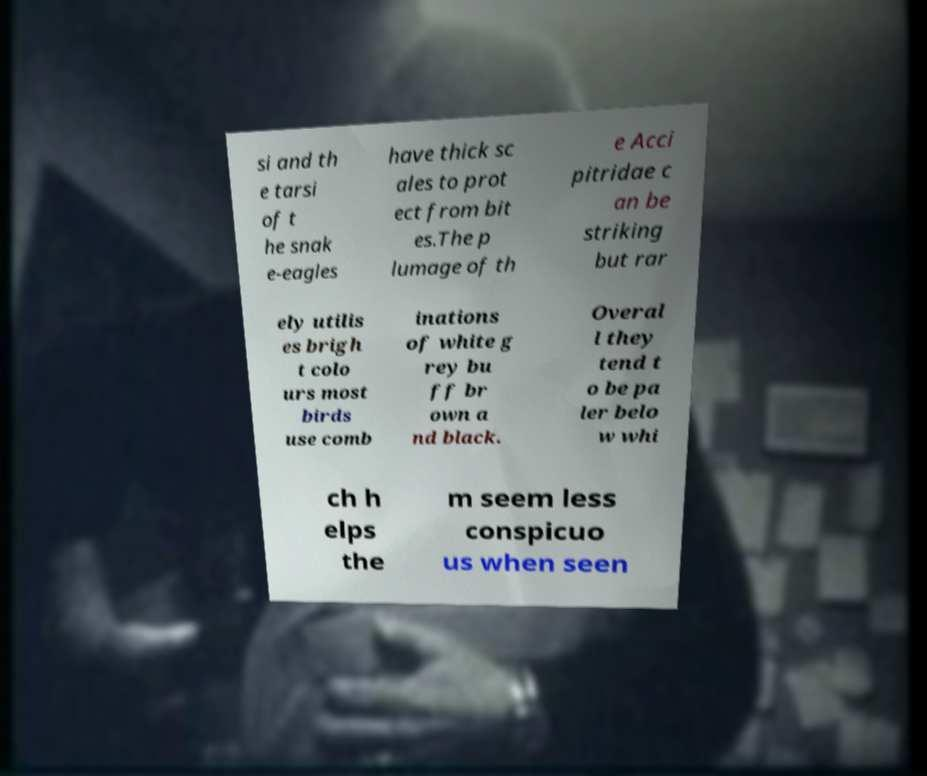Could you extract and type out the text from this image? si and th e tarsi of t he snak e-eagles have thick sc ales to prot ect from bit es.The p lumage of th e Acci pitridae c an be striking but rar ely utilis es brigh t colo urs most birds use comb inations of white g rey bu ff br own a nd black. Overal l they tend t o be pa ler belo w whi ch h elps the m seem less conspicuo us when seen 